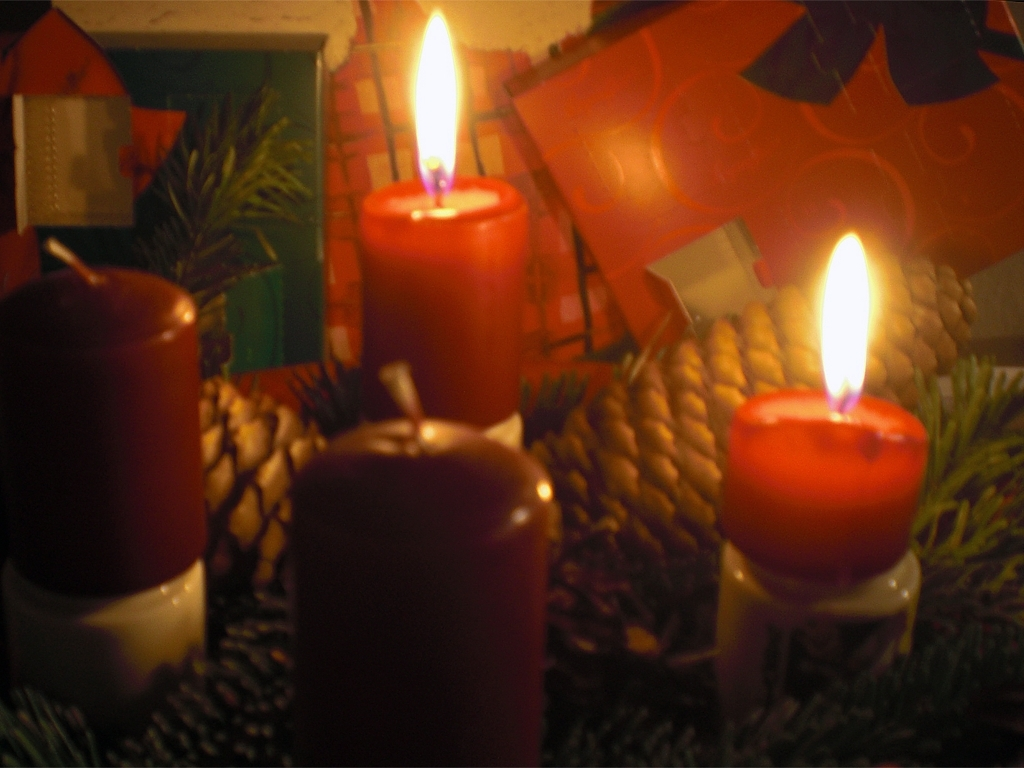What mood does this image evoke? The lit candles and soft lighting combine to evoke a mood of coziness and tranquility. The arrangement suggests a celebratory or reflective moment, often associated with intimate gatherings or traditional holiday celebrations, such as Christmas. The ambiance is one of warmth and peacefulness, inviting observers to slow down and enjoy the moment. What might be the significance of the candles in this context? Candles are deeply symbolic, often representing light and warmth. In the context of the image, which indicates a holiday setting, the candles could symbolize the bringing of light during the darker winter months. They are also a traditional element of many holiday celebrations, symbolizing hope, reverence, and the passing of time as they burn down. 